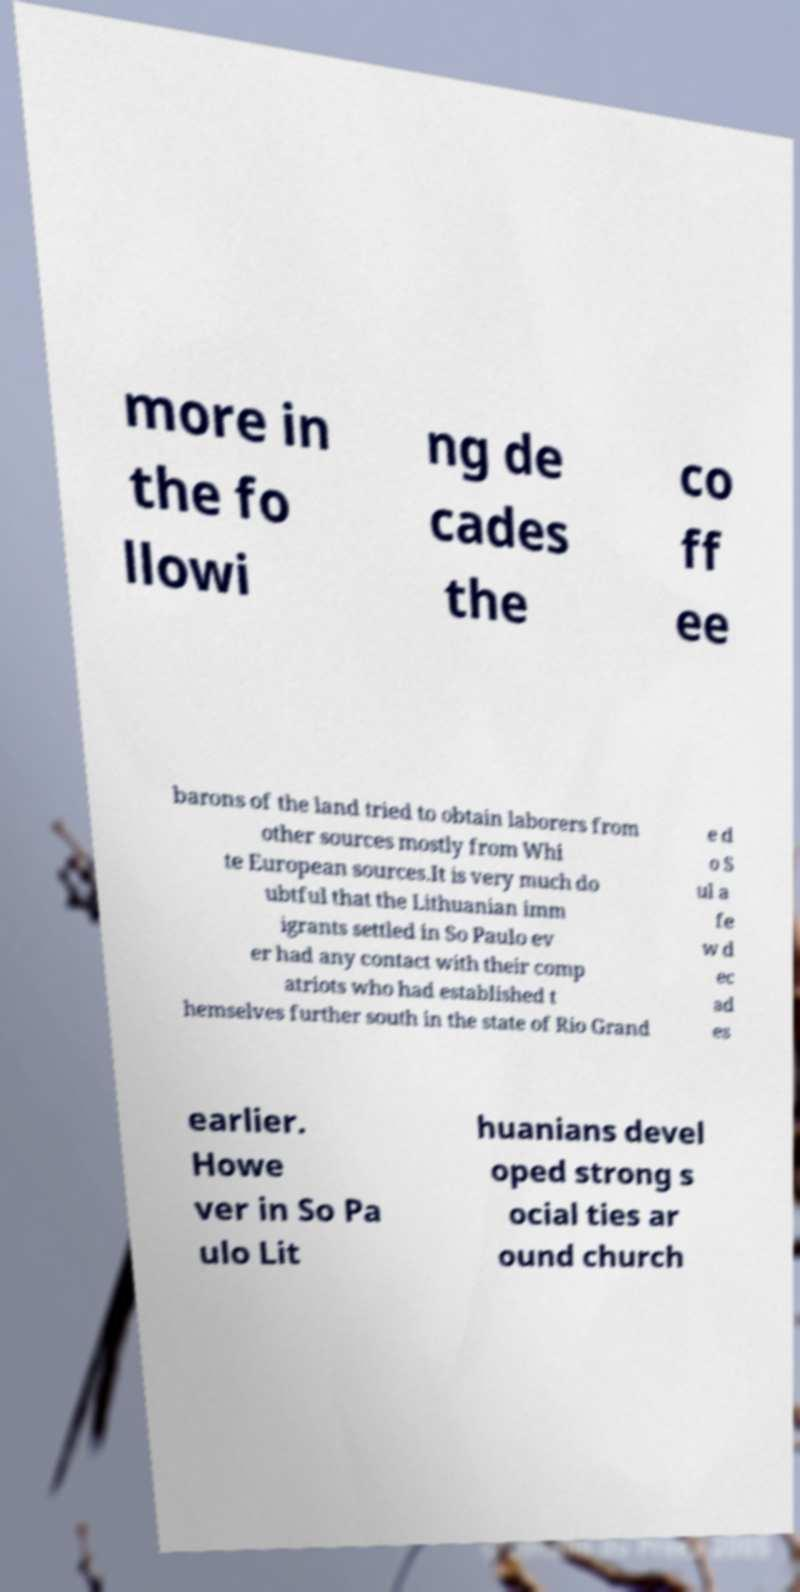Can you read and provide the text displayed in the image?This photo seems to have some interesting text. Can you extract and type it out for me? more in the fo llowi ng de cades the co ff ee barons of the land tried to obtain laborers from other sources mostly from Whi te European sources.It is very much do ubtful that the Lithuanian imm igrants settled in So Paulo ev er had any contact with their comp atriots who had established t hemselves further south in the state of Rio Grand e d o S ul a fe w d ec ad es earlier. Howe ver in So Pa ulo Lit huanians devel oped strong s ocial ties ar ound church 